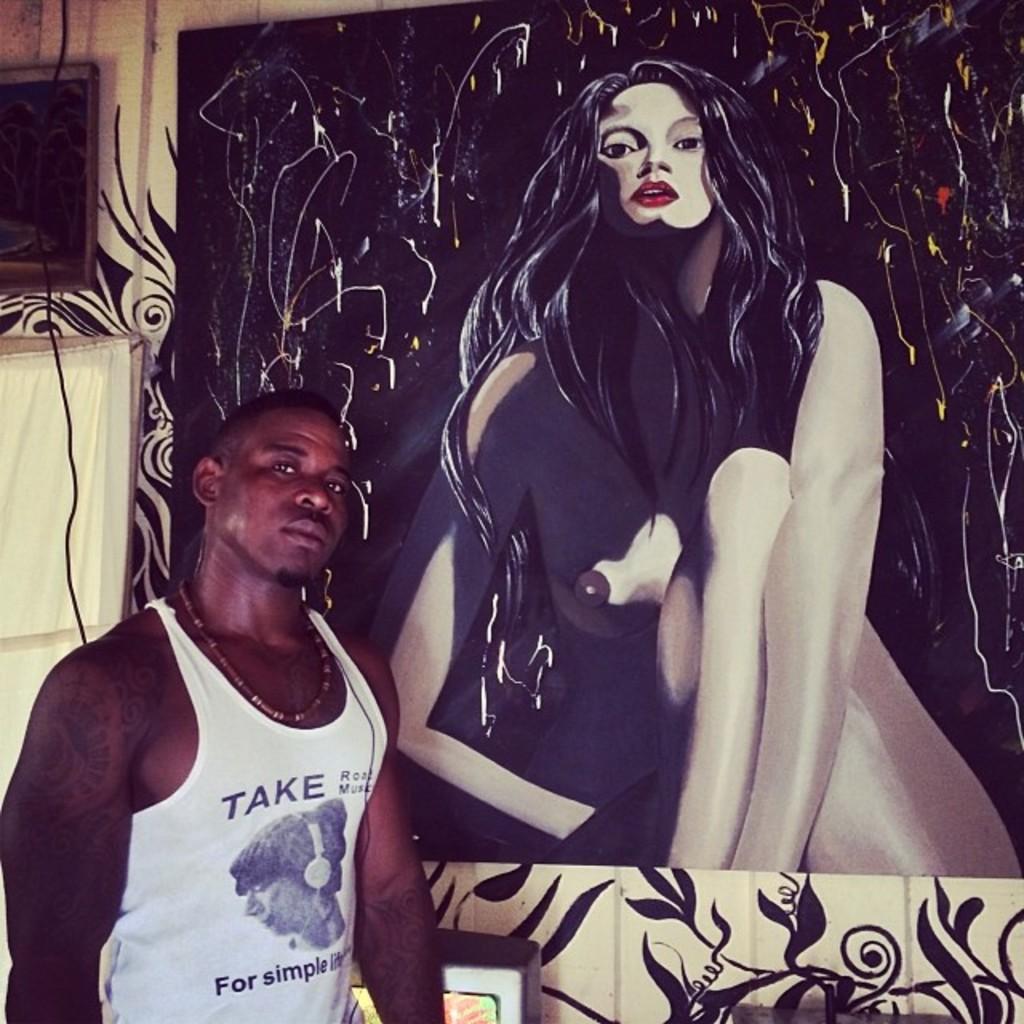What does his shirt say?
Your answer should be very brief. Take. 